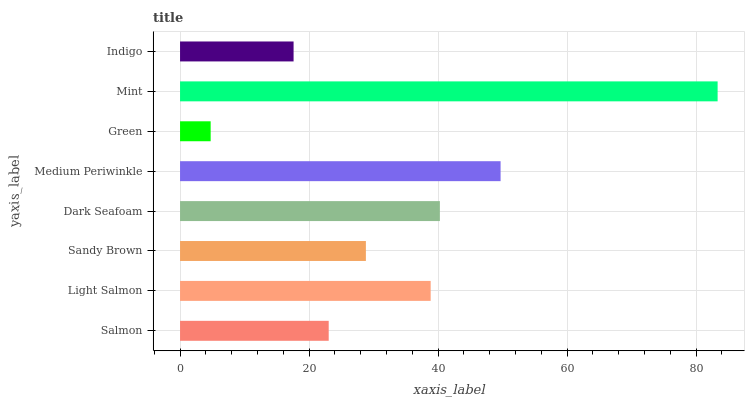Is Green the minimum?
Answer yes or no. Yes. Is Mint the maximum?
Answer yes or no. Yes. Is Light Salmon the minimum?
Answer yes or no. No. Is Light Salmon the maximum?
Answer yes or no. No. Is Light Salmon greater than Salmon?
Answer yes or no. Yes. Is Salmon less than Light Salmon?
Answer yes or no. Yes. Is Salmon greater than Light Salmon?
Answer yes or no. No. Is Light Salmon less than Salmon?
Answer yes or no. No. Is Light Salmon the high median?
Answer yes or no. Yes. Is Sandy Brown the low median?
Answer yes or no. Yes. Is Indigo the high median?
Answer yes or no. No. Is Green the low median?
Answer yes or no. No. 